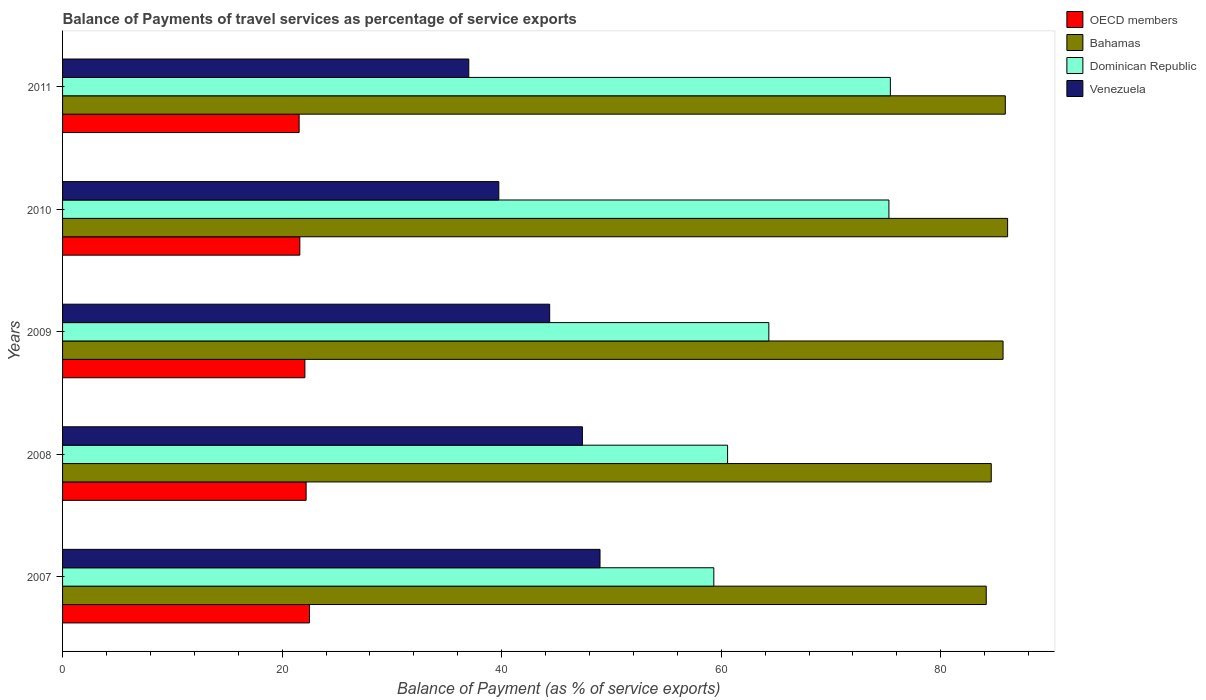How many different coloured bars are there?
Offer a very short reply. 4. How many groups of bars are there?
Provide a short and direct response. 5. Are the number of bars per tick equal to the number of legend labels?
Your answer should be compact. Yes. How many bars are there on the 3rd tick from the bottom?
Give a very brief answer. 4. What is the balance of payments of travel services in OECD members in 2009?
Keep it short and to the point. 22.07. Across all years, what is the maximum balance of payments of travel services in Dominican Republic?
Give a very brief answer. 75.41. Across all years, what is the minimum balance of payments of travel services in Dominican Republic?
Offer a very short reply. 59.33. In which year was the balance of payments of travel services in Bahamas maximum?
Offer a terse response. 2010. In which year was the balance of payments of travel services in Dominican Republic minimum?
Make the answer very short. 2007. What is the total balance of payments of travel services in Venezuela in the graph?
Make the answer very short. 217.44. What is the difference between the balance of payments of travel services in Bahamas in 2008 and that in 2011?
Offer a very short reply. -1.28. What is the difference between the balance of payments of travel services in Venezuela in 2008 and the balance of payments of travel services in Bahamas in 2007?
Provide a short and direct response. -36.79. What is the average balance of payments of travel services in Bahamas per year?
Make the answer very short. 85.28. In the year 2009, what is the difference between the balance of payments of travel services in Dominican Republic and balance of payments of travel services in Venezuela?
Your answer should be very brief. 19.97. What is the ratio of the balance of payments of travel services in Venezuela in 2007 to that in 2008?
Keep it short and to the point. 1.03. What is the difference between the highest and the second highest balance of payments of travel services in Venezuela?
Your answer should be very brief. 1.6. What is the difference between the highest and the lowest balance of payments of travel services in Dominican Republic?
Offer a very short reply. 16.08. In how many years, is the balance of payments of travel services in Venezuela greater than the average balance of payments of travel services in Venezuela taken over all years?
Give a very brief answer. 3. Is it the case that in every year, the sum of the balance of payments of travel services in Dominican Republic and balance of payments of travel services in Venezuela is greater than the sum of balance of payments of travel services in Bahamas and balance of payments of travel services in OECD members?
Ensure brevity in your answer.  Yes. What does the 4th bar from the top in 2011 represents?
Your answer should be very brief. OECD members. What does the 2nd bar from the bottom in 2009 represents?
Provide a succinct answer. Bahamas. How many years are there in the graph?
Ensure brevity in your answer.  5. What is the difference between two consecutive major ticks on the X-axis?
Make the answer very short. 20. How many legend labels are there?
Ensure brevity in your answer.  4. What is the title of the graph?
Keep it short and to the point. Balance of Payments of travel services as percentage of service exports. Does "Guyana" appear as one of the legend labels in the graph?
Offer a very short reply. No. What is the label or title of the X-axis?
Your answer should be very brief. Balance of Payment (as % of service exports). What is the label or title of the Y-axis?
Make the answer very short. Years. What is the Balance of Payment (as % of service exports) of OECD members in 2007?
Give a very brief answer. 22.5. What is the Balance of Payment (as % of service exports) in Bahamas in 2007?
Offer a very short reply. 84.14. What is the Balance of Payment (as % of service exports) in Dominican Republic in 2007?
Offer a very short reply. 59.33. What is the Balance of Payment (as % of service exports) of Venezuela in 2007?
Provide a short and direct response. 48.96. What is the Balance of Payment (as % of service exports) in OECD members in 2008?
Keep it short and to the point. 22.19. What is the Balance of Payment (as % of service exports) of Bahamas in 2008?
Offer a terse response. 84.6. What is the Balance of Payment (as % of service exports) of Dominican Republic in 2008?
Provide a succinct answer. 60.58. What is the Balance of Payment (as % of service exports) in Venezuela in 2008?
Your answer should be very brief. 47.36. What is the Balance of Payment (as % of service exports) of OECD members in 2009?
Provide a short and direct response. 22.07. What is the Balance of Payment (as % of service exports) in Bahamas in 2009?
Your answer should be compact. 85.68. What is the Balance of Payment (as % of service exports) of Dominican Republic in 2009?
Make the answer very short. 64.34. What is the Balance of Payment (as % of service exports) of Venezuela in 2009?
Provide a succinct answer. 44.37. What is the Balance of Payment (as % of service exports) of OECD members in 2010?
Your response must be concise. 21.61. What is the Balance of Payment (as % of service exports) in Bahamas in 2010?
Your answer should be very brief. 86.09. What is the Balance of Payment (as % of service exports) in Dominican Republic in 2010?
Your response must be concise. 75.28. What is the Balance of Payment (as % of service exports) in Venezuela in 2010?
Your answer should be very brief. 39.74. What is the Balance of Payment (as % of service exports) of OECD members in 2011?
Offer a terse response. 21.55. What is the Balance of Payment (as % of service exports) of Bahamas in 2011?
Keep it short and to the point. 85.88. What is the Balance of Payment (as % of service exports) in Dominican Republic in 2011?
Offer a very short reply. 75.41. What is the Balance of Payment (as % of service exports) in Venezuela in 2011?
Keep it short and to the point. 37.01. Across all years, what is the maximum Balance of Payment (as % of service exports) of OECD members?
Keep it short and to the point. 22.5. Across all years, what is the maximum Balance of Payment (as % of service exports) in Bahamas?
Offer a very short reply. 86.09. Across all years, what is the maximum Balance of Payment (as % of service exports) in Dominican Republic?
Make the answer very short. 75.41. Across all years, what is the maximum Balance of Payment (as % of service exports) in Venezuela?
Your answer should be very brief. 48.96. Across all years, what is the minimum Balance of Payment (as % of service exports) of OECD members?
Keep it short and to the point. 21.55. Across all years, what is the minimum Balance of Payment (as % of service exports) in Bahamas?
Provide a succinct answer. 84.14. Across all years, what is the minimum Balance of Payment (as % of service exports) in Dominican Republic?
Offer a terse response. 59.33. Across all years, what is the minimum Balance of Payment (as % of service exports) of Venezuela?
Provide a short and direct response. 37.01. What is the total Balance of Payment (as % of service exports) of OECD members in the graph?
Ensure brevity in your answer.  109.92. What is the total Balance of Payment (as % of service exports) in Bahamas in the graph?
Offer a very short reply. 426.4. What is the total Balance of Payment (as % of service exports) of Dominican Republic in the graph?
Offer a very short reply. 334.94. What is the total Balance of Payment (as % of service exports) of Venezuela in the graph?
Keep it short and to the point. 217.44. What is the difference between the Balance of Payment (as % of service exports) in OECD members in 2007 and that in 2008?
Give a very brief answer. 0.31. What is the difference between the Balance of Payment (as % of service exports) in Bahamas in 2007 and that in 2008?
Give a very brief answer. -0.46. What is the difference between the Balance of Payment (as % of service exports) in Dominican Republic in 2007 and that in 2008?
Your answer should be compact. -1.25. What is the difference between the Balance of Payment (as % of service exports) in Venezuela in 2007 and that in 2008?
Offer a terse response. 1.6. What is the difference between the Balance of Payment (as % of service exports) of OECD members in 2007 and that in 2009?
Your response must be concise. 0.42. What is the difference between the Balance of Payment (as % of service exports) of Bahamas in 2007 and that in 2009?
Make the answer very short. -1.53. What is the difference between the Balance of Payment (as % of service exports) of Dominican Republic in 2007 and that in 2009?
Give a very brief answer. -5.01. What is the difference between the Balance of Payment (as % of service exports) of Venezuela in 2007 and that in 2009?
Offer a terse response. 4.59. What is the difference between the Balance of Payment (as % of service exports) in OECD members in 2007 and that in 2010?
Your response must be concise. 0.88. What is the difference between the Balance of Payment (as % of service exports) in Bahamas in 2007 and that in 2010?
Keep it short and to the point. -1.95. What is the difference between the Balance of Payment (as % of service exports) in Dominican Republic in 2007 and that in 2010?
Offer a very short reply. -15.95. What is the difference between the Balance of Payment (as % of service exports) of Venezuela in 2007 and that in 2010?
Offer a terse response. 9.22. What is the difference between the Balance of Payment (as % of service exports) of OECD members in 2007 and that in 2011?
Offer a terse response. 0.95. What is the difference between the Balance of Payment (as % of service exports) of Bahamas in 2007 and that in 2011?
Ensure brevity in your answer.  -1.74. What is the difference between the Balance of Payment (as % of service exports) of Dominican Republic in 2007 and that in 2011?
Your response must be concise. -16.08. What is the difference between the Balance of Payment (as % of service exports) of Venezuela in 2007 and that in 2011?
Give a very brief answer. 11.96. What is the difference between the Balance of Payment (as % of service exports) in OECD members in 2008 and that in 2009?
Offer a terse response. 0.11. What is the difference between the Balance of Payment (as % of service exports) in Bahamas in 2008 and that in 2009?
Offer a very short reply. -1.08. What is the difference between the Balance of Payment (as % of service exports) in Dominican Republic in 2008 and that in 2009?
Your response must be concise. -3.76. What is the difference between the Balance of Payment (as % of service exports) of Venezuela in 2008 and that in 2009?
Offer a very short reply. 2.98. What is the difference between the Balance of Payment (as % of service exports) in OECD members in 2008 and that in 2010?
Offer a terse response. 0.57. What is the difference between the Balance of Payment (as % of service exports) of Bahamas in 2008 and that in 2010?
Your answer should be very brief. -1.49. What is the difference between the Balance of Payment (as % of service exports) of Dominican Republic in 2008 and that in 2010?
Ensure brevity in your answer.  -14.7. What is the difference between the Balance of Payment (as % of service exports) of Venezuela in 2008 and that in 2010?
Your response must be concise. 7.61. What is the difference between the Balance of Payment (as % of service exports) in OECD members in 2008 and that in 2011?
Make the answer very short. 0.64. What is the difference between the Balance of Payment (as % of service exports) of Bahamas in 2008 and that in 2011?
Ensure brevity in your answer.  -1.28. What is the difference between the Balance of Payment (as % of service exports) in Dominican Republic in 2008 and that in 2011?
Provide a succinct answer. -14.83. What is the difference between the Balance of Payment (as % of service exports) of Venezuela in 2008 and that in 2011?
Ensure brevity in your answer.  10.35. What is the difference between the Balance of Payment (as % of service exports) in OECD members in 2009 and that in 2010?
Your answer should be compact. 0.46. What is the difference between the Balance of Payment (as % of service exports) in Bahamas in 2009 and that in 2010?
Your response must be concise. -0.42. What is the difference between the Balance of Payment (as % of service exports) in Dominican Republic in 2009 and that in 2010?
Provide a short and direct response. -10.94. What is the difference between the Balance of Payment (as % of service exports) in Venezuela in 2009 and that in 2010?
Provide a succinct answer. 4.63. What is the difference between the Balance of Payment (as % of service exports) in OECD members in 2009 and that in 2011?
Provide a short and direct response. 0.52. What is the difference between the Balance of Payment (as % of service exports) in Bahamas in 2009 and that in 2011?
Your response must be concise. -0.21. What is the difference between the Balance of Payment (as % of service exports) of Dominican Republic in 2009 and that in 2011?
Provide a short and direct response. -11.07. What is the difference between the Balance of Payment (as % of service exports) of Venezuela in 2009 and that in 2011?
Ensure brevity in your answer.  7.37. What is the difference between the Balance of Payment (as % of service exports) in OECD members in 2010 and that in 2011?
Provide a short and direct response. 0.06. What is the difference between the Balance of Payment (as % of service exports) in Bahamas in 2010 and that in 2011?
Give a very brief answer. 0.21. What is the difference between the Balance of Payment (as % of service exports) of Dominican Republic in 2010 and that in 2011?
Make the answer very short. -0.13. What is the difference between the Balance of Payment (as % of service exports) of Venezuela in 2010 and that in 2011?
Offer a very short reply. 2.74. What is the difference between the Balance of Payment (as % of service exports) of OECD members in 2007 and the Balance of Payment (as % of service exports) of Bahamas in 2008?
Keep it short and to the point. -62.11. What is the difference between the Balance of Payment (as % of service exports) of OECD members in 2007 and the Balance of Payment (as % of service exports) of Dominican Republic in 2008?
Keep it short and to the point. -38.09. What is the difference between the Balance of Payment (as % of service exports) in OECD members in 2007 and the Balance of Payment (as % of service exports) in Venezuela in 2008?
Ensure brevity in your answer.  -24.86. What is the difference between the Balance of Payment (as % of service exports) of Bahamas in 2007 and the Balance of Payment (as % of service exports) of Dominican Republic in 2008?
Ensure brevity in your answer.  23.56. What is the difference between the Balance of Payment (as % of service exports) of Bahamas in 2007 and the Balance of Payment (as % of service exports) of Venezuela in 2008?
Keep it short and to the point. 36.79. What is the difference between the Balance of Payment (as % of service exports) of Dominican Republic in 2007 and the Balance of Payment (as % of service exports) of Venezuela in 2008?
Offer a terse response. 11.97. What is the difference between the Balance of Payment (as % of service exports) of OECD members in 2007 and the Balance of Payment (as % of service exports) of Bahamas in 2009?
Your answer should be very brief. -63.18. What is the difference between the Balance of Payment (as % of service exports) in OECD members in 2007 and the Balance of Payment (as % of service exports) in Dominican Republic in 2009?
Keep it short and to the point. -41.84. What is the difference between the Balance of Payment (as % of service exports) of OECD members in 2007 and the Balance of Payment (as % of service exports) of Venezuela in 2009?
Your answer should be compact. -21.88. What is the difference between the Balance of Payment (as % of service exports) of Bahamas in 2007 and the Balance of Payment (as % of service exports) of Dominican Republic in 2009?
Your response must be concise. 19.8. What is the difference between the Balance of Payment (as % of service exports) of Bahamas in 2007 and the Balance of Payment (as % of service exports) of Venezuela in 2009?
Ensure brevity in your answer.  39.77. What is the difference between the Balance of Payment (as % of service exports) in Dominican Republic in 2007 and the Balance of Payment (as % of service exports) in Venezuela in 2009?
Ensure brevity in your answer.  14.95. What is the difference between the Balance of Payment (as % of service exports) in OECD members in 2007 and the Balance of Payment (as % of service exports) in Bahamas in 2010?
Keep it short and to the point. -63.6. What is the difference between the Balance of Payment (as % of service exports) in OECD members in 2007 and the Balance of Payment (as % of service exports) in Dominican Republic in 2010?
Your answer should be compact. -52.79. What is the difference between the Balance of Payment (as % of service exports) of OECD members in 2007 and the Balance of Payment (as % of service exports) of Venezuela in 2010?
Your answer should be compact. -17.25. What is the difference between the Balance of Payment (as % of service exports) of Bahamas in 2007 and the Balance of Payment (as % of service exports) of Dominican Republic in 2010?
Make the answer very short. 8.86. What is the difference between the Balance of Payment (as % of service exports) of Bahamas in 2007 and the Balance of Payment (as % of service exports) of Venezuela in 2010?
Ensure brevity in your answer.  44.4. What is the difference between the Balance of Payment (as % of service exports) in Dominican Republic in 2007 and the Balance of Payment (as % of service exports) in Venezuela in 2010?
Make the answer very short. 19.59. What is the difference between the Balance of Payment (as % of service exports) of OECD members in 2007 and the Balance of Payment (as % of service exports) of Bahamas in 2011?
Provide a succinct answer. -63.39. What is the difference between the Balance of Payment (as % of service exports) in OECD members in 2007 and the Balance of Payment (as % of service exports) in Dominican Republic in 2011?
Keep it short and to the point. -52.92. What is the difference between the Balance of Payment (as % of service exports) of OECD members in 2007 and the Balance of Payment (as % of service exports) of Venezuela in 2011?
Make the answer very short. -14.51. What is the difference between the Balance of Payment (as % of service exports) of Bahamas in 2007 and the Balance of Payment (as % of service exports) of Dominican Republic in 2011?
Make the answer very short. 8.73. What is the difference between the Balance of Payment (as % of service exports) in Bahamas in 2007 and the Balance of Payment (as % of service exports) in Venezuela in 2011?
Offer a very short reply. 47.14. What is the difference between the Balance of Payment (as % of service exports) in Dominican Republic in 2007 and the Balance of Payment (as % of service exports) in Venezuela in 2011?
Offer a very short reply. 22.32. What is the difference between the Balance of Payment (as % of service exports) in OECD members in 2008 and the Balance of Payment (as % of service exports) in Bahamas in 2009?
Give a very brief answer. -63.49. What is the difference between the Balance of Payment (as % of service exports) of OECD members in 2008 and the Balance of Payment (as % of service exports) of Dominican Republic in 2009?
Make the answer very short. -42.15. What is the difference between the Balance of Payment (as % of service exports) of OECD members in 2008 and the Balance of Payment (as % of service exports) of Venezuela in 2009?
Provide a succinct answer. -22.19. What is the difference between the Balance of Payment (as % of service exports) of Bahamas in 2008 and the Balance of Payment (as % of service exports) of Dominican Republic in 2009?
Make the answer very short. 20.26. What is the difference between the Balance of Payment (as % of service exports) of Bahamas in 2008 and the Balance of Payment (as % of service exports) of Venezuela in 2009?
Keep it short and to the point. 40.23. What is the difference between the Balance of Payment (as % of service exports) of Dominican Republic in 2008 and the Balance of Payment (as % of service exports) of Venezuela in 2009?
Give a very brief answer. 16.21. What is the difference between the Balance of Payment (as % of service exports) of OECD members in 2008 and the Balance of Payment (as % of service exports) of Bahamas in 2010?
Provide a short and direct response. -63.9. What is the difference between the Balance of Payment (as % of service exports) in OECD members in 2008 and the Balance of Payment (as % of service exports) in Dominican Republic in 2010?
Your response must be concise. -53.09. What is the difference between the Balance of Payment (as % of service exports) of OECD members in 2008 and the Balance of Payment (as % of service exports) of Venezuela in 2010?
Offer a terse response. -17.55. What is the difference between the Balance of Payment (as % of service exports) in Bahamas in 2008 and the Balance of Payment (as % of service exports) in Dominican Republic in 2010?
Ensure brevity in your answer.  9.32. What is the difference between the Balance of Payment (as % of service exports) of Bahamas in 2008 and the Balance of Payment (as % of service exports) of Venezuela in 2010?
Give a very brief answer. 44.86. What is the difference between the Balance of Payment (as % of service exports) of Dominican Republic in 2008 and the Balance of Payment (as % of service exports) of Venezuela in 2010?
Offer a terse response. 20.84. What is the difference between the Balance of Payment (as % of service exports) in OECD members in 2008 and the Balance of Payment (as % of service exports) in Bahamas in 2011?
Offer a very short reply. -63.69. What is the difference between the Balance of Payment (as % of service exports) of OECD members in 2008 and the Balance of Payment (as % of service exports) of Dominican Republic in 2011?
Your answer should be compact. -53.22. What is the difference between the Balance of Payment (as % of service exports) in OECD members in 2008 and the Balance of Payment (as % of service exports) in Venezuela in 2011?
Offer a very short reply. -14.82. What is the difference between the Balance of Payment (as % of service exports) in Bahamas in 2008 and the Balance of Payment (as % of service exports) in Dominican Republic in 2011?
Ensure brevity in your answer.  9.19. What is the difference between the Balance of Payment (as % of service exports) of Bahamas in 2008 and the Balance of Payment (as % of service exports) of Venezuela in 2011?
Keep it short and to the point. 47.6. What is the difference between the Balance of Payment (as % of service exports) in Dominican Republic in 2008 and the Balance of Payment (as % of service exports) in Venezuela in 2011?
Keep it short and to the point. 23.58. What is the difference between the Balance of Payment (as % of service exports) in OECD members in 2009 and the Balance of Payment (as % of service exports) in Bahamas in 2010?
Your answer should be very brief. -64.02. What is the difference between the Balance of Payment (as % of service exports) in OECD members in 2009 and the Balance of Payment (as % of service exports) in Dominican Republic in 2010?
Offer a very short reply. -53.21. What is the difference between the Balance of Payment (as % of service exports) of OECD members in 2009 and the Balance of Payment (as % of service exports) of Venezuela in 2010?
Offer a very short reply. -17.67. What is the difference between the Balance of Payment (as % of service exports) in Bahamas in 2009 and the Balance of Payment (as % of service exports) in Dominican Republic in 2010?
Ensure brevity in your answer.  10.4. What is the difference between the Balance of Payment (as % of service exports) of Bahamas in 2009 and the Balance of Payment (as % of service exports) of Venezuela in 2010?
Give a very brief answer. 45.94. What is the difference between the Balance of Payment (as % of service exports) of Dominican Republic in 2009 and the Balance of Payment (as % of service exports) of Venezuela in 2010?
Give a very brief answer. 24.6. What is the difference between the Balance of Payment (as % of service exports) in OECD members in 2009 and the Balance of Payment (as % of service exports) in Bahamas in 2011?
Your answer should be compact. -63.81. What is the difference between the Balance of Payment (as % of service exports) in OECD members in 2009 and the Balance of Payment (as % of service exports) in Dominican Republic in 2011?
Give a very brief answer. -53.34. What is the difference between the Balance of Payment (as % of service exports) of OECD members in 2009 and the Balance of Payment (as % of service exports) of Venezuela in 2011?
Give a very brief answer. -14.93. What is the difference between the Balance of Payment (as % of service exports) in Bahamas in 2009 and the Balance of Payment (as % of service exports) in Dominican Republic in 2011?
Your response must be concise. 10.27. What is the difference between the Balance of Payment (as % of service exports) of Bahamas in 2009 and the Balance of Payment (as % of service exports) of Venezuela in 2011?
Make the answer very short. 48.67. What is the difference between the Balance of Payment (as % of service exports) of Dominican Republic in 2009 and the Balance of Payment (as % of service exports) of Venezuela in 2011?
Keep it short and to the point. 27.33. What is the difference between the Balance of Payment (as % of service exports) in OECD members in 2010 and the Balance of Payment (as % of service exports) in Bahamas in 2011?
Ensure brevity in your answer.  -64.27. What is the difference between the Balance of Payment (as % of service exports) in OECD members in 2010 and the Balance of Payment (as % of service exports) in Dominican Republic in 2011?
Your answer should be compact. -53.8. What is the difference between the Balance of Payment (as % of service exports) of OECD members in 2010 and the Balance of Payment (as % of service exports) of Venezuela in 2011?
Provide a succinct answer. -15.39. What is the difference between the Balance of Payment (as % of service exports) of Bahamas in 2010 and the Balance of Payment (as % of service exports) of Dominican Republic in 2011?
Make the answer very short. 10.68. What is the difference between the Balance of Payment (as % of service exports) in Bahamas in 2010 and the Balance of Payment (as % of service exports) in Venezuela in 2011?
Ensure brevity in your answer.  49.09. What is the difference between the Balance of Payment (as % of service exports) in Dominican Republic in 2010 and the Balance of Payment (as % of service exports) in Venezuela in 2011?
Make the answer very short. 38.28. What is the average Balance of Payment (as % of service exports) of OECD members per year?
Your answer should be very brief. 21.98. What is the average Balance of Payment (as % of service exports) of Bahamas per year?
Give a very brief answer. 85.28. What is the average Balance of Payment (as % of service exports) in Dominican Republic per year?
Offer a very short reply. 66.99. What is the average Balance of Payment (as % of service exports) of Venezuela per year?
Provide a succinct answer. 43.49. In the year 2007, what is the difference between the Balance of Payment (as % of service exports) in OECD members and Balance of Payment (as % of service exports) in Bahamas?
Provide a succinct answer. -61.65. In the year 2007, what is the difference between the Balance of Payment (as % of service exports) in OECD members and Balance of Payment (as % of service exports) in Dominican Republic?
Offer a terse response. -36.83. In the year 2007, what is the difference between the Balance of Payment (as % of service exports) of OECD members and Balance of Payment (as % of service exports) of Venezuela?
Provide a succinct answer. -26.47. In the year 2007, what is the difference between the Balance of Payment (as % of service exports) in Bahamas and Balance of Payment (as % of service exports) in Dominican Republic?
Ensure brevity in your answer.  24.82. In the year 2007, what is the difference between the Balance of Payment (as % of service exports) of Bahamas and Balance of Payment (as % of service exports) of Venezuela?
Provide a succinct answer. 35.18. In the year 2007, what is the difference between the Balance of Payment (as % of service exports) of Dominican Republic and Balance of Payment (as % of service exports) of Venezuela?
Your answer should be compact. 10.37. In the year 2008, what is the difference between the Balance of Payment (as % of service exports) in OECD members and Balance of Payment (as % of service exports) in Bahamas?
Offer a very short reply. -62.41. In the year 2008, what is the difference between the Balance of Payment (as % of service exports) of OECD members and Balance of Payment (as % of service exports) of Dominican Republic?
Offer a terse response. -38.39. In the year 2008, what is the difference between the Balance of Payment (as % of service exports) in OECD members and Balance of Payment (as % of service exports) in Venezuela?
Your answer should be very brief. -25.17. In the year 2008, what is the difference between the Balance of Payment (as % of service exports) of Bahamas and Balance of Payment (as % of service exports) of Dominican Republic?
Make the answer very short. 24.02. In the year 2008, what is the difference between the Balance of Payment (as % of service exports) of Bahamas and Balance of Payment (as % of service exports) of Venezuela?
Your answer should be very brief. 37.25. In the year 2008, what is the difference between the Balance of Payment (as % of service exports) of Dominican Republic and Balance of Payment (as % of service exports) of Venezuela?
Offer a terse response. 13.23. In the year 2009, what is the difference between the Balance of Payment (as % of service exports) in OECD members and Balance of Payment (as % of service exports) in Bahamas?
Keep it short and to the point. -63.6. In the year 2009, what is the difference between the Balance of Payment (as % of service exports) of OECD members and Balance of Payment (as % of service exports) of Dominican Republic?
Your answer should be very brief. -42.27. In the year 2009, what is the difference between the Balance of Payment (as % of service exports) of OECD members and Balance of Payment (as % of service exports) of Venezuela?
Your answer should be very brief. -22.3. In the year 2009, what is the difference between the Balance of Payment (as % of service exports) of Bahamas and Balance of Payment (as % of service exports) of Dominican Republic?
Offer a very short reply. 21.34. In the year 2009, what is the difference between the Balance of Payment (as % of service exports) in Bahamas and Balance of Payment (as % of service exports) in Venezuela?
Give a very brief answer. 41.3. In the year 2009, what is the difference between the Balance of Payment (as % of service exports) in Dominican Republic and Balance of Payment (as % of service exports) in Venezuela?
Keep it short and to the point. 19.97. In the year 2010, what is the difference between the Balance of Payment (as % of service exports) in OECD members and Balance of Payment (as % of service exports) in Bahamas?
Your response must be concise. -64.48. In the year 2010, what is the difference between the Balance of Payment (as % of service exports) in OECD members and Balance of Payment (as % of service exports) in Dominican Republic?
Make the answer very short. -53.67. In the year 2010, what is the difference between the Balance of Payment (as % of service exports) of OECD members and Balance of Payment (as % of service exports) of Venezuela?
Provide a short and direct response. -18.13. In the year 2010, what is the difference between the Balance of Payment (as % of service exports) of Bahamas and Balance of Payment (as % of service exports) of Dominican Republic?
Ensure brevity in your answer.  10.81. In the year 2010, what is the difference between the Balance of Payment (as % of service exports) of Bahamas and Balance of Payment (as % of service exports) of Venezuela?
Your response must be concise. 46.35. In the year 2010, what is the difference between the Balance of Payment (as % of service exports) in Dominican Republic and Balance of Payment (as % of service exports) in Venezuela?
Provide a succinct answer. 35.54. In the year 2011, what is the difference between the Balance of Payment (as % of service exports) of OECD members and Balance of Payment (as % of service exports) of Bahamas?
Your answer should be compact. -64.33. In the year 2011, what is the difference between the Balance of Payment (as % of service exports) in OECD members and Balance of Payment (as % of service exports) in Dominican Republic?
Provide a succinct answer. -53.86. In the year 2011, what is the difference between the Balance of Payment (as % of service exports) in OECD members and Balance of Payment (as % of service exports) in Venezuela?
Provide a short and direct response. -15.46. In the year 2011, what is the difference between the Balance of Payment (as % of service exports) of Bahamas and Balance of Payment (as % of service exports) of Dominican Republic?
Your answer should be very brief. 10.47. In the year 2011, what is the difference between the Balance of Payment (as % of service exports) in Bahamas and Balance of Payment (as % of service exports) in Venezuela?
Keep it short and to the point. 48.88. In the year 2011, what is the difference between the Balance of Payment (as % of service exports) in Dominican Republic and Balance of Payment (as % of service exports) in Venezuela?
Your answer should be very brief. 38.41. What is the ratio of the Balance of Payment (as % of service exports) of OECD members in 2007 to that in 2008?
Give a very brief answer. 1.01. What is the ratio of the Balance of Payment (as % of service exports) of Bahamas in 2007 to that in 2008?
Provide a succinct answer. 0.99. What is the ratio of the Balance of Payment (as % of service exports) in Dominican Republic in 2007 to that in 2008?
Your answer should be very brief. 0.98. What is the ratio of the Balance of Payment (as % of service exports) of Venezuela in 2007 to that in 2008?
Provide a succinct answer. 1.03. What is the ratio of the Balance of Payment (as % of service exports) of OECD members in 2007 to that in 2009?
Provide a succinct answer. 1.02. What is the ratio of the Balance of Payment (as % of service exports) of Bahamas in 2007 to that in 2009?
Keep it short and to the point. 0.98. What is the ratio of the Balance of Payment (as % of service exports) in Dominican Republic in 2007 to that in 2009?
Offer a very short reply. 0.92. What is the ratio of the Balance of Payment (as % of service exports) of Venezuela in 2007 to that in 2009?
Provide a short and direct response. 1.1. What is the ratio of the Balance of Payment (as % of service exports) in OECD members in 2007 to that in 2010?
Offer a terse response. 1.04. What is the ratio of the Balance of Payment (as % of service exports) in Bahamas in 2007 to that in 2010?
Your answer should be very brief. 0.98. What is the ratio of the Balance of Payment (as % of service exports) of Dominican Republic in 2007 to that in 2010?
Give a very brief answer. 0.79. What is the ratio of the Balance of Payment (as % of service exports) of Venezuela in 2007 to that in 2010?
Keep it short and to the point. 1.23. What is the ratio of the Balance of Payment (as % of service exports) of OECD members in 2007 to that in 2011?
Your response must be concise. 1.04. What is the ratio of the Balance of Payment (as % of service exports) of Bahamas in 2007 to that in 2011?
Offer a very short reply. 0.98. What is the ratio of the Balance of Payment (as % of service exports) of Dominican Republic in 2007 to that in 2011?
Offer a very short reply. 0.79. What is the ratio of the Balance of Payment (as % of service exports) in Venezuela in 2007 to that in 2011?
Keep it short and to the point. 1.32. What is the ratio of the Balance of Payment (as % of service exports) in Bahamas in 2008 to that in 2009?
Keep it short and to the point. 0.99. What is the ratio of the Balance of Payment (as % of service exports) in Dominican Republic in 2008 to that in 2009?
Keep it short and to the point. 0.94. What is the ratio of the Balance of Payment (as % of service exports) in Venezuela in 2008 to that in 2009?
Provide a short and direct response. 1.07. What is the ratio of the Balance of Payment (as % of service exports) of OECD members in 2008 to that in 2010?
Provide a short and direct response. 1.03. What is the ratio of the Balance of Payment (as % of service exports) in Bahamas in 2008 to that in 2010?
Your answer should be very brief. 0.98. What is the ratio of the Balance of Payment (as % of service exports) in Dominican Republic in 2008 to that in 2010?
Provide a short and direct response. 0.8. What is the ratio of the Balance of Payment (as % of service exports) of Venezuela in 2008 to that in 2010?
Offer a very short reply. 1.19. What is the ratio of the Balance of Payment (as % of service exports) of OECD members in 2008 to that in 2011?
Provide a succinct answer. 1.03. What is the ratio of the Balance of Payment (as % of service exports) in Bahamas in 2008 to that in 2011?
Your answer should be compact. 0.99. What is the ratio of the Balance of Payment (as % of service exports) of Dominican Republic in 2008 to that in 2011?
Your answer should be compact. 0.8. What is the ratio of the Balance of Payment (as % of service exports) of Venezuela in 2008 to that in 2011?
Make the answer very short. 1.28. What is the ratio of the Balance of Payment (as % of service exports) of OECD members in 2009 to that in 2010?
Ensure brevity in your answer.  1.02. What is the ratio of the Balance of Payment (as % of service exports) in Dominican Republic in 2009 to that in 2010?
Ensure brevity in your answer.  0.85. What is the ratio of the Balance of Payment (as % of service exports) in Venezuela in 2009 to that in 2010?
Offer a very short reply. 1.12. What is the ratio of the Balance of Payment (as % of service exports) in OECD members in 2009 to that in 2011?
Your answer should be very brief. 1.02. What is the ratio of the Balance of Payment (as % of service exports) in Dominican Republic in 2009 to that in 2011?
Provide a succinct answer. 0.85. What is the ratio of the Balance of Payment (as % of service exports) of Venezuela in 2009 to that in 2011?
Your response must be concise. 1.2. What is the ratio of the Balance of Payment (as % of service exports) of OECD members in 2010 to that in 2011?
Keep it short and to the point. 1. What is the ratio of the Balance of Payment (as % of service exports) of Bahamas in 2010 to that in 2011?
Provide a short and direct response. 1. What is the ratio of the Balance of Payment (as % of service exports) of Venezuela in 2010 to that in 2011?
Offer a very short reply. 1.07. What is the difference between the highest and the second highest Balance of Payment (as % of service exports) in OECD members?
Provide a short and direct response. 0.31. What is the difference between the highest and the second highest Balance of Payment (as % of service exports) of Bahamas?
Your answer should be very brief. 0.21. What is the difference between the highest and the second highest Balance of Payment (as % of service exports) in Dominican Republic?
Your answer should be very brief. 0.13. What is the difference between the highest and the second highest Balance of Payment (as % of service exports) of Venezuela?
Your answer should be very brief. 1.6. What is the difference between the highest and the lowest Balance of Payment (as % of service exports) in OECD members?
Your response must be concise. 0.95. What is the difference between the highest and the lowest Balance of Payment (as % of service exports) in Bahamas?
Your answer should be very brief. 1.95. What is the difference between the highest and the lowest Balance of Payment (as % of service exports) in Dominican Republic?
Your answer should be compact. 16.08. What is the difference between the highest and the lowest Balance of Payment (as % of service exports) in Venezuela?
Keep it short and to the point. 11.96. 